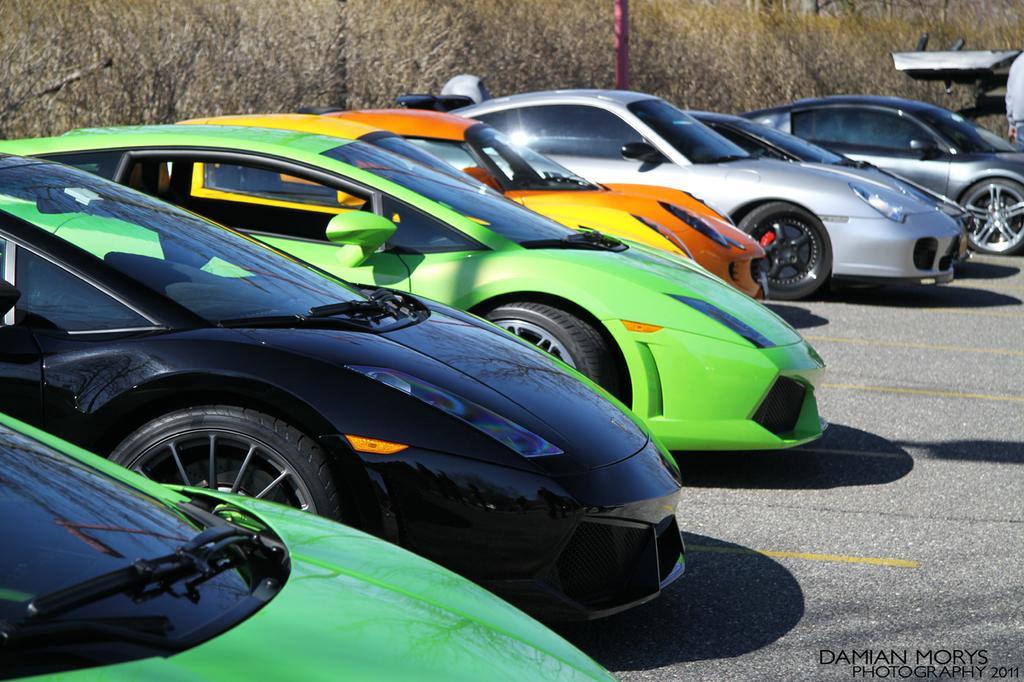How would you summarize this image in a sentence or two? In this picture I can see number of cars in front and I see that they're on the road. In the background I can see few plants and I can see a person on the right top corner of this picture and I see the watermark on the right bottom corner of this picture. 